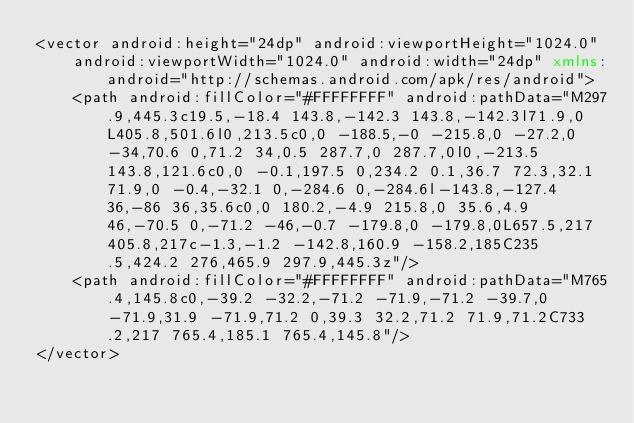<code> <loc_0><loc_0><loc_500><loc_500><_XML_><vector android:height="24dp" android:viewportHeight="1024.0"
    android:viewportWidth="1024.0" android:width="24dp" xmlns:android="http://schemas.android.com/apk/res/android">
    <path android:fillColor="#FFFFFFFF" android:pathData="M297.9,445.3c19.5,-18.4 143.8,-142.3 143.8,-142.3l71.9,0L405.8,501.6l0,213.5c0,0 -188.5,-0 -215.8,0 -27.2,0 -34,70.6 0,71.2 34,0.5 287.7,0 287.7,0l0,-213.5 143.8,121.6c0,0 -0.1,197.5 0,234.2 0.1,36.7 72.3,32.1 71.9,0 -0.4,-32.1 0,-284.6 0,-284.6l-143.8,-127.4 36,-86 36,35.6c0,0 180.2,-4.9 215.8,0 35.6,4.9 46,-70.5 0,-71.2 -46,-0.7 -179.8,0 -179.8,0L657.5,217 405.8,217c-1.3,-1.2 -142.8,160.9 -158.2,185C235.5,424.2 276,465.9 297.9,445.3z"/>
    <path android:fillColor="#FFFFFFFF" android:pathData="M765.4,145.8c0,-39.2 -32.2,-71.2 -71.9,-71.2 -39.7,0 -71.9,31.9 -71.9,71.2 0,39.3 32.2,71.2 71.9,71.2C733.2,217 765.4,185.1 765.4,145.8"/>
</vector>
</code> 